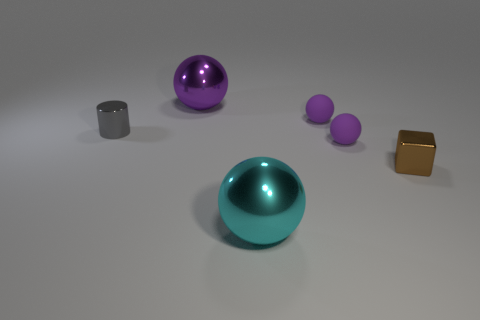How many other things are there of the same material as the big cyan thing? There are two objects in the image that appear to be made of a similar glossy material as the large cyan sphere. These are the small purple sphere and the larger purple sphere. Although their colors differ, the sheen and reflection suggest a similar material, possibly a type of polished stone or coated metal. 